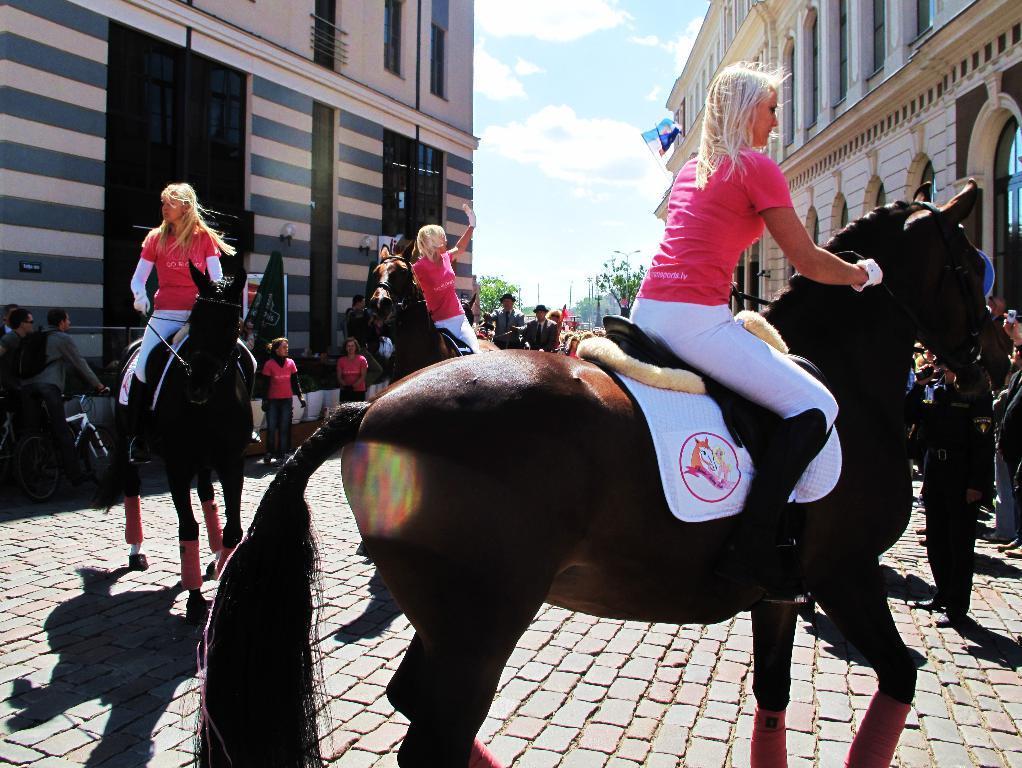In one or two sentences, can you explain what this image depicts? In this image there are three women sitting on horse. At the right side there are few people standing. Left side there is a person carrying a bag is holding a bicycle. Left side there are few persons standing. Both sides of image there are buildings. Background there are few trees and sky having some clouds. 